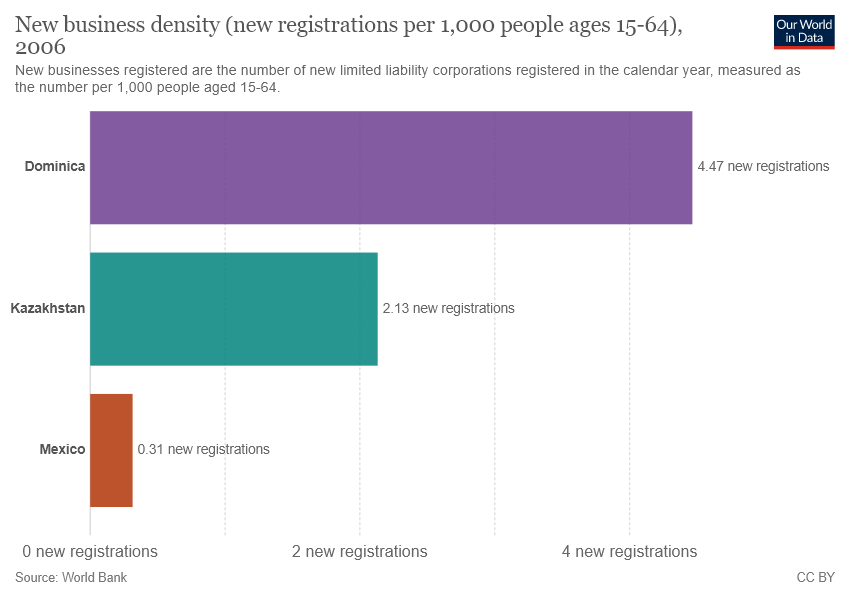Indicate a few pertinent items in this graphic. The bar represents 3 colors in total. The combined distribution of Mexico and Kazakhstan is not higher than that of Dominica. 